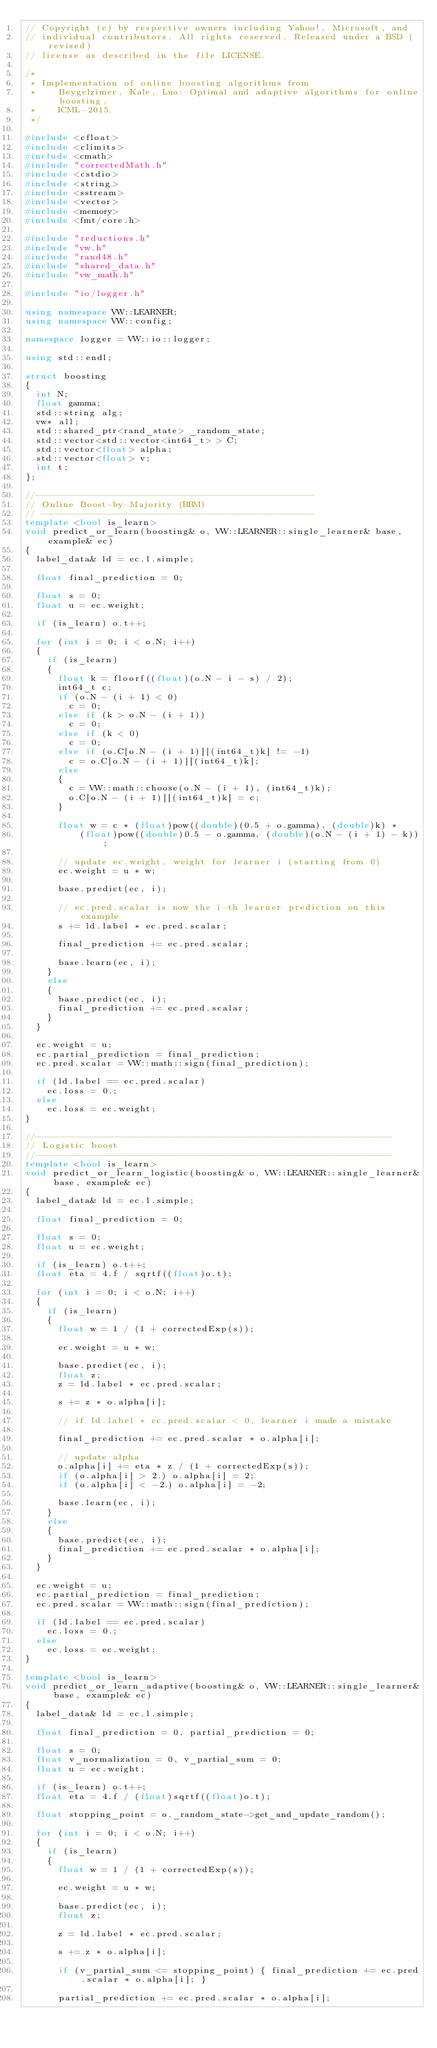<code> <loc_0><loc_0><loc_500><loc_500><_C++_>// Copyright (c) by respective owners including Yahoo!, Microsoft, and
// individual contributors. All rights reserved. Released under a BSD (revised)
// license as described in the file LICENSE.

/*
 * Implementation of online boosting algorithms from
 *    Beygelzimer, Kale, Luo: Optimal and adaptive algorithms for online boosting,
 *    ICML-2015.
 */

#include <cfloat>
#include <climits>
#include <cmath>
#include "correctedMath.h"
#include <cstdio>
#include <string>
#include <sstream>
#include <vector>
#include <memory>
#include <fmt/core.h>

#include "reductions.h"
#include "vw.h"
#include "rand48.h"
#include "shared_data.h"
#include "vw_math.h"

#include "io/logger.h"

using namespace VW::LEARNER;
using namespace VW::config;

namespace logger = VW::io::logger;

using std::endl;

struct boosting
{
  int N;
  float gamma;
  std::string alg;
  vw* all;
  std::shared_ptr<rand_state> _random_state;
  std::vector<std::vector<int64_t> > C;
  std::vector<float> alpha;
  std::vector<float> v;
  int t;
};

//---------------------------------------------------
// Online Boost-by-Majority (BBM)
// --------------------------------------------------
template <bool is_learn>
void predict_or_learn(boosting& o, VW::LEARNER::single_learner& base, example& ec)
{
  label_data& ld = ec.l.simple;

  float final_prediction = 0;

  float s = 0;
  float u = ec.weight;

  if (is_learn) o.t++;

  for (int i = 0; i < o.N; i++)
  {
    if (is_learn)
    {
      float k = floorf((float)(o.N - i - s) / 2);
      int64_t c;
      if (o.N - (i + 1) < 0)
        c = 0;
      else if (k > o.N - (i + 1))
        c = 0;
      else if (k < 0)
        c = 0;
      else if (o.C[o.N - (i + 1)][(int64_t)k] != -1)
        c = o.C[o.N - (i + 1)][(int64_t)k];
      else
      {
        c = VW::math::choose(o.N - (i + 1), (int64_t)k);
        o.C[o.N - (i + 1)][(int64_t)k] = c;
      }

      float w = c * (float)pow((double)(0.5 + o.gamma), (double)k) *
          (float)pow((double)0.5 - o.gamma, (double)(o.N - (i + 1) - k));

      // update ec.weight, weight for learner i (starting from 0)
      ec.weight = u * w;

      base.predict(ec, i);

      // ec.pred.scalar is now the i-th learner prediction on this example
      s += ld.label * ec.pred.scalar;

      final_prediction += ec.pred.scalar;

      base.learn(ec, i);
    }
    else
    {
      base.predict(ec, i);
      final_prediction += ec.pred.scalar;
    }
  }

  ec.weight = u;
  ec.partial_prediction = final_prediction;
  ec.pred.scalar = VW::math::sign(final_prediction);

  if (ld.label == ec.pred.scalar)
    ec.loss = 0.;
  else
    ec.loss = ec.weight;
}

//-----------------------------------------------------------------
// Logistic boost
//-----------------------------------------------------------------
template <bool is_learn>
void predict_or_learn_logistic(boosting& o, VW::LEARNER::single_learner& base, example& ec)
{
  label_data& ld = ec.l.simple;

  float final_prediction = 0;

  float s = 0;
  float u = ec.weight;

  if (is_learn) o.t++;
  float eta = 4.f / sqrtf((float)o.t);

  for (int i = 0; i < o.N; i++)
  {
    if (is_learn)
    {
      float w = 1 / (1 + correctedExp(s));

      ec.weight = u * w;

      base.predict(ec, i);
      float z;
      z = ld.label * ec.pred.scalar;

      s += z * o.alpha[i];

      // if ld.label * ec.pred.scalar < 0, learner i made a mistake

      final_prediction += ec.pred.scalar * o.alpha[i];

      // update alpha
      o.alpha[i] += eta * z / (1 + correctedExp(s));
      if (o.alpha[i] > 2.) o.alpha[i] = 2;
      if (o.alpha[i] < -2.) o.alpha[i] = -2;

      base.learn(ec, i);
    }
    else
    {
      base.predict(ec, i);
      final_prediction += ec.pred.scalar * o.alpha[i];
    }
  }

  ec.weight = u;
  ec.partial_prediction = final_prediction;
  ec.pred.scalar = VW::math::sign(final_prediction);

  if (ld.label == ec.pred.scalar)
    ec.loss = 0.;
  else
    ec.loss = ec.weight;
}

template <bool is_learn>
void predict_or_learn_adaptive(boosting& o, VW::LEARNER::single_learner& base, example& ec)
{
  label_data& ld = ec.l.simple;

  float final_prediction = 0, partial_prediction = 0;

  float s = 0;
  float v_normalization = 0, v_partial_sum = 0;
  float u = ec.weight;

  if (is_learn) o.t++;
  float eta = 4.f / (float)sqrtf((float)o.t);

  float stopping_point = o._random_state->get_and_update_random();

  for (int i = 0; i < o.N; i++)
  {
    if (is_learn)
    {
      float w = 1 / (1 + correctedExp(s));

      ec.weight = u * w;

      base.predict(ec, i);
      float z;

      z = ld.label * ec.pred.scalar;

      s += z * o.alpha[i];

      if (v_partial_sum <= stopping_point) { final_prediction += ec.pred.scalar * o.alpha[i]; }

      partial_prediction += ec.pred.scalar * o.alpha[i];
</code> 